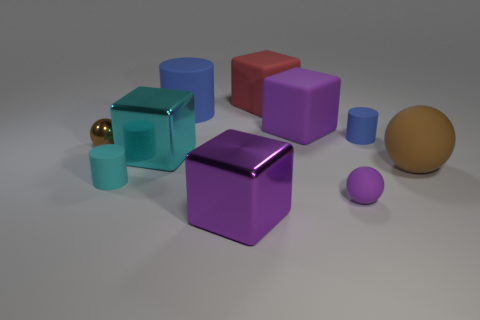What is the shape of the small brown metal object?
Your answer should be very brief. Sphere. How many big matte things are there?
Your answer should be compact. 4. There is a big thing that is in front of the tiny cylinder that is in front of the brown metal thing; what is its color?
Offer a very short reply. Purple. There is a rubber sphere that is the same size as the brown metal object; what color is it?
Your answer should be compact. Purple. Are there any tiny cylinders of the same color as the small metal sphere?
Offer a very short reply. No. Are there any red matte spheres?
Provide a succinct answer. No. What is the shape of the blue matte object right of the small rubber ball?
Ensure brevity in your answer.  Cylinder. How many big purple objects are both to the left of the big purple matte thing and behind the tiny metal thing?
Provide a short and direct response. 0. What number of other things are there of the same size as the red matte block?
Give a very brief answer. 5. Does the large rubber thing that is to the right of the tiny purple matte thing have the same shape as the big purple thing that is in front of the tiny blue matte cylinder?
Your response must be concise. No. 